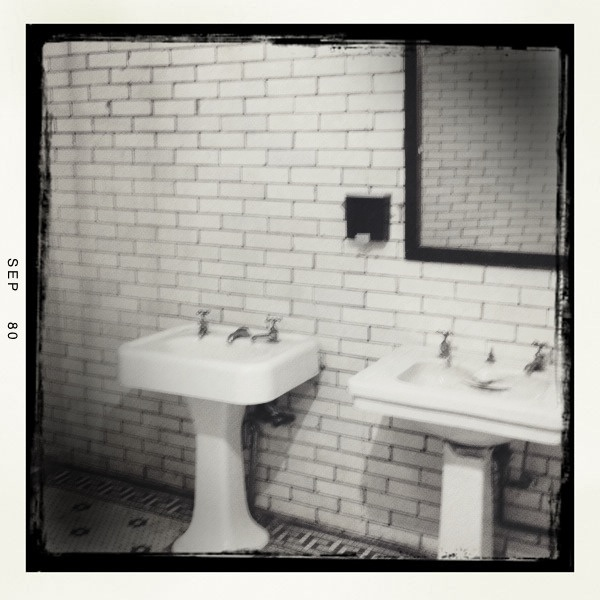Describe the objects in this image and their specific colors. I can see sink in ivory, lightgray, darkgray, and gray tones and sink in ivory, lightgray, darkgray, and gray tones in this image. 